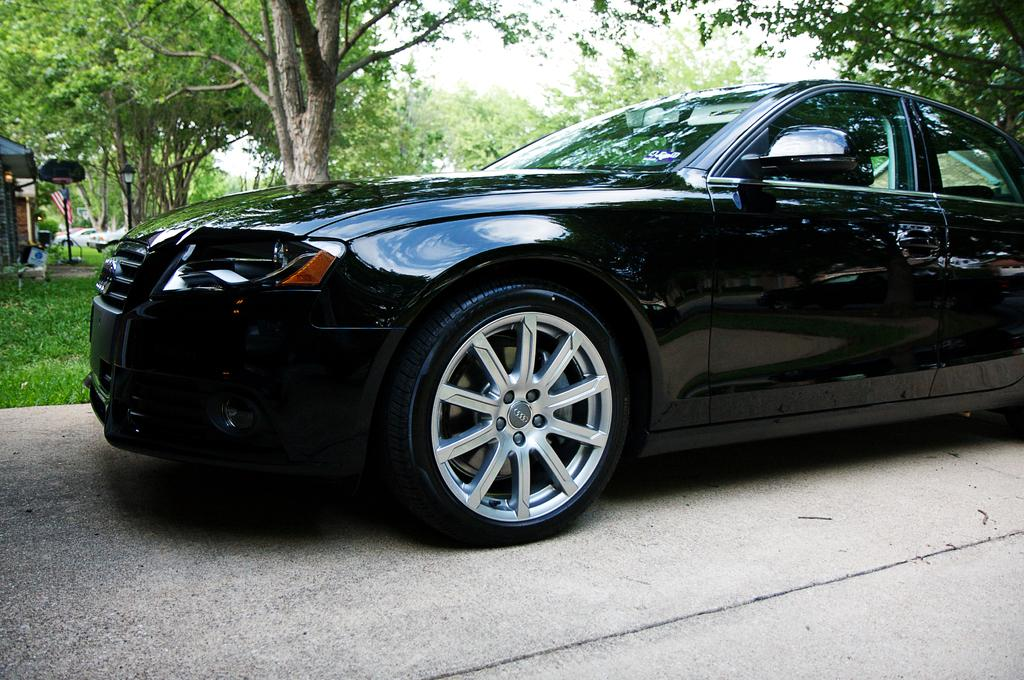What is parked on the road in the image? There is a car parked on the road in the image. What can be seen on the backside of the image? There is a group of trees, grass, and a pole visible on the backside of the image. What is visible in the sky in the image? The sky is visible in the image. What type of cannon is being used to illuminate the car in the image? There is no cannon present in the image, and the car is not being illuminated by any cannon. 